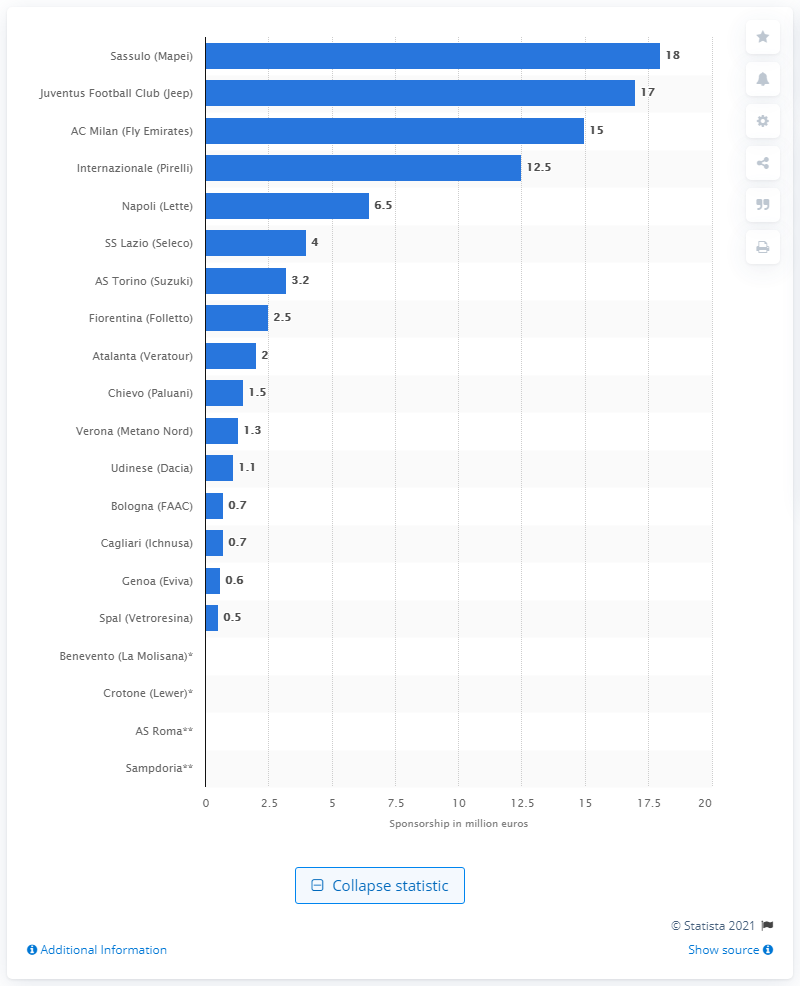Identify some key points in this picture. The sponsorship deal between Jeep and the festival was worth $17 million. Sassulo's jersey kit sponsorship deal was worth 18... 